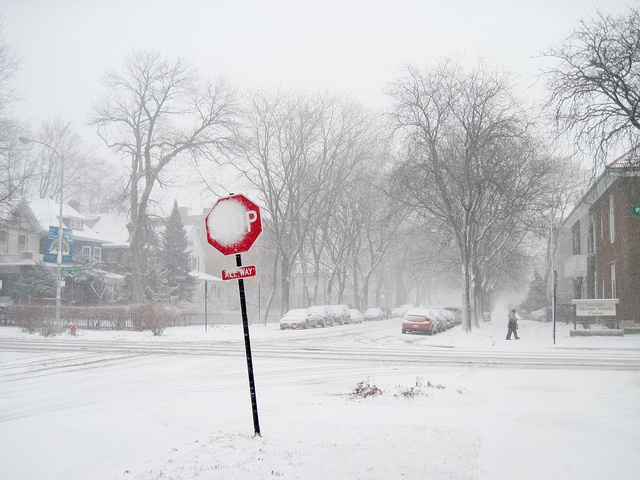Describe the objects in this image and their specific colors. I can see stop sign in lightgray, brown, and darkgray tones, car in lightgray, darkgray, and gray tones, car in lightgray, darkgray, and gray tones, car in lightgray and darkgray tones, and car in lightgray and darkgray tones in this image. 